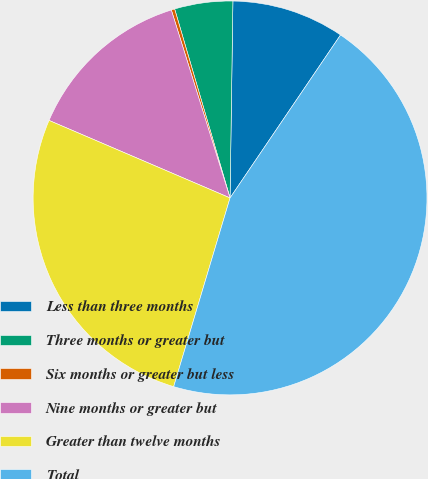Convert chart to OTSL. <chart><loc_0><loc_0><loc_500><loc_500><pie_chart><fcel>Less than three months<fcel>Three months or greater but<fcel>Six months or greater but less<fcel>Nine months or greater but<fcel>Greater than twelve months<fcel>Total<nl><fcel>9.25%<fcel>4.77%<fcel>0.28%<fcel>13.74%<fcel>26.82%<fcel>45.14%<nl></chart> 